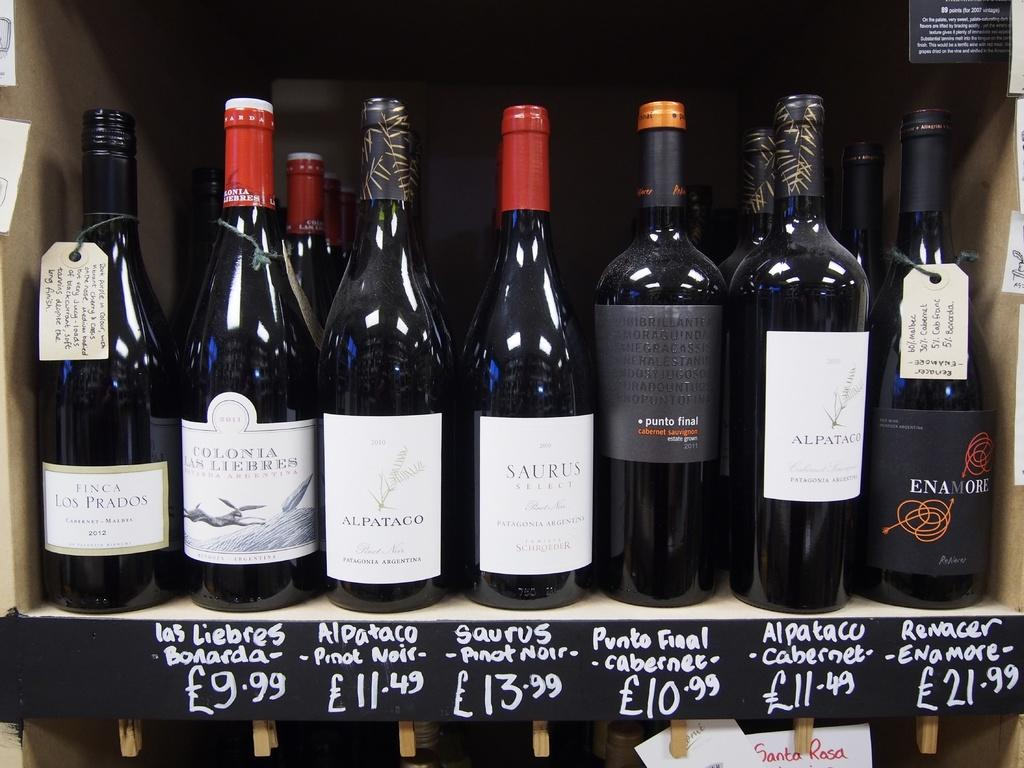<image>
Give a short and clear explanation of the subsequent image. the price of 13.99 on a wine bottle 